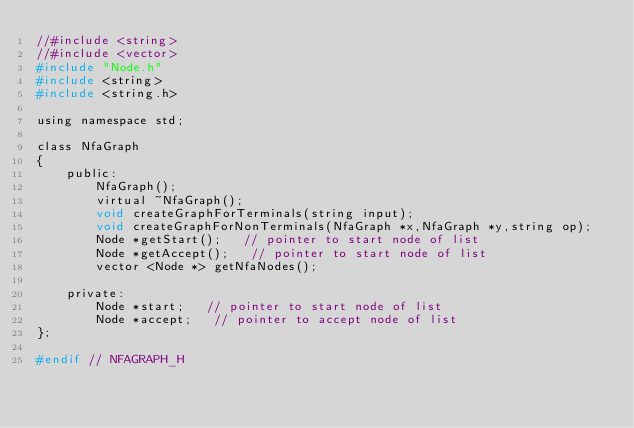Convert code to text. <code><loc_0><loc_0><loc_500><loc_500><_C_>//#include <string>
//#include <vector>
#include "Node.h"
#include <string>
#include <string.h>

using namespace std;

class NfaGraph
{
    public:
        NfaGraph();
        virtual ~NfaGraph();
        void createGraphForTerminals(string input);
        void createGraphForNonTerminals(NfaGraph *x,NfaGraph *y,string op);
        Node *getStart();   // pointer to start node of list
        Node *getAccept();   // pointer to start node of list
        vector <Node *> getNfaNodes();

    private:
        Node *start;   // pointer to start node of list
        Node *accept;   // pointer to accept node of list
};

#endif // NFAGRAPH_H
</code> 